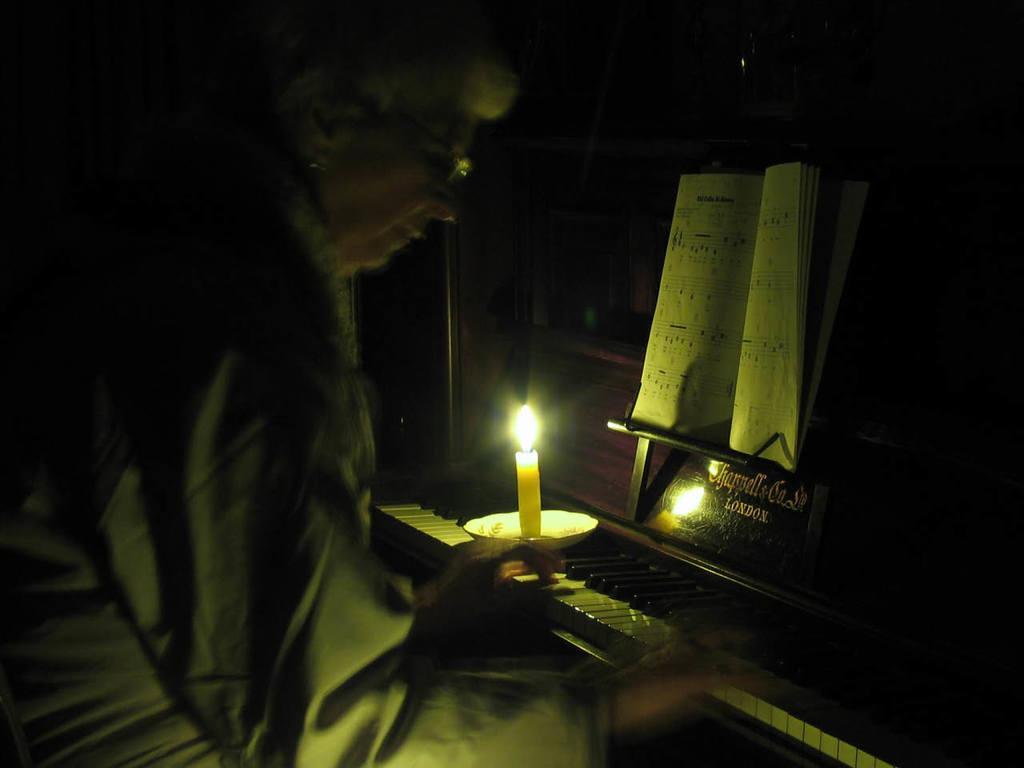Describe this image in one or two sentences. In this image we can see a person wearing the glasses and playing the guitar. We can also see a candle with the flame. We can see a plate and also the book and a name board. 